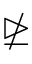Convert formula to latex. <formula><loc_0><loc_0><loc_500><loc_500>\ntrianglerighteq</formula> 